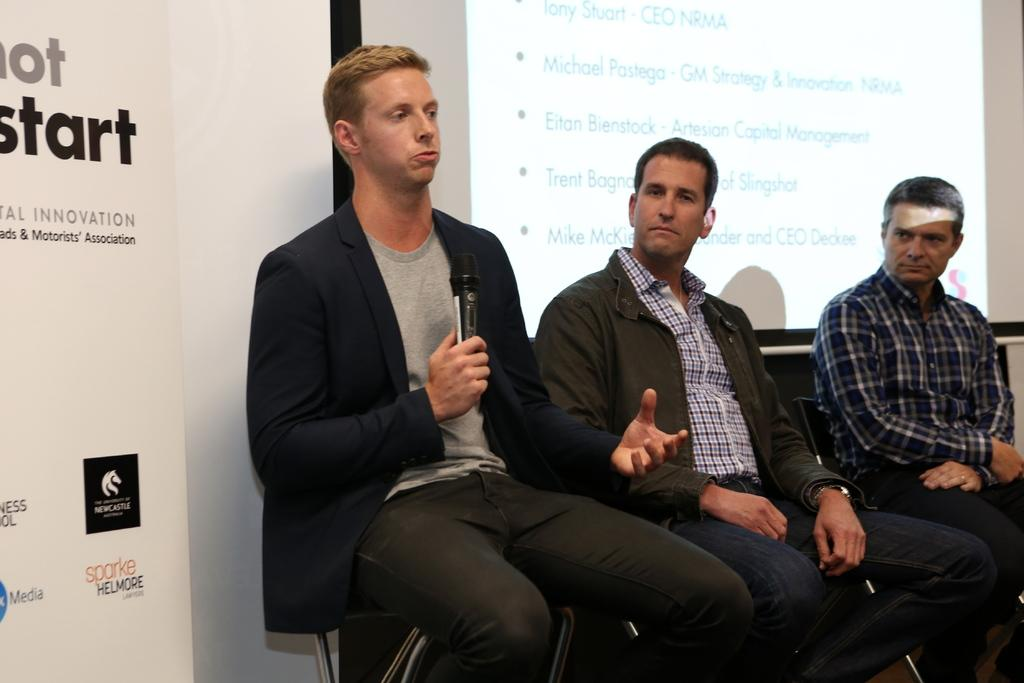How many people are in the image? There are three men in the image. What are the men doing in the image? The men are sitting on chairs. What is located behind the men? There is a projector screen behind the men. What can be seen on the left side of the image? There is a board on the left side of the image. What type of sleet can be seen falling on the board in the image? There is no sleet present in the image; it is an indoor setting with no precipitation. What iron object is being used by one of the men in the image? There is no iron object being used by any of the men in the image. 